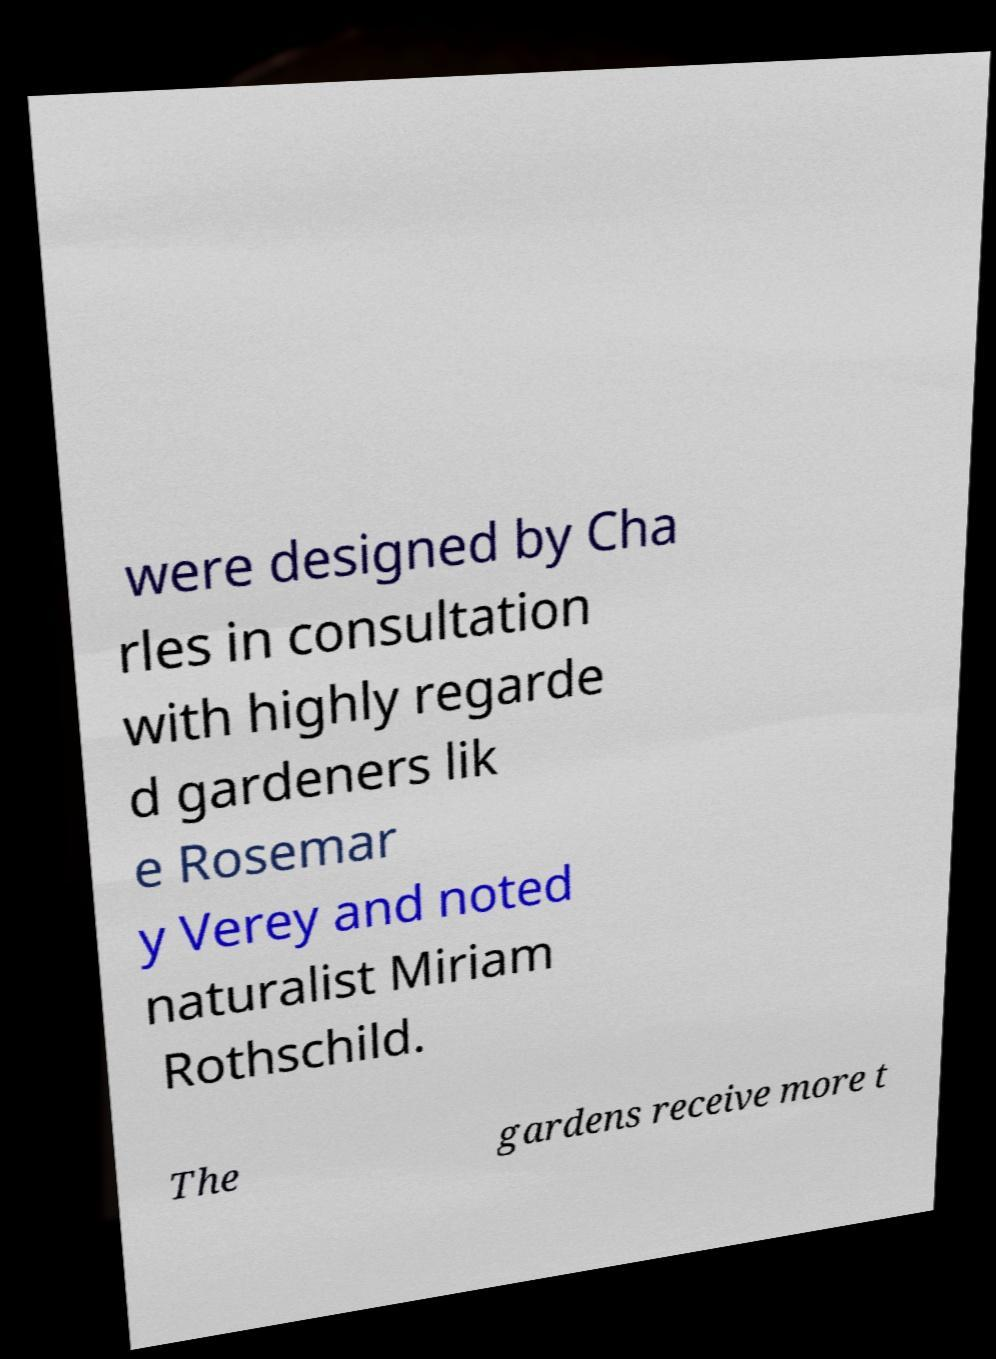Please identify and transcribe the text found in this image. were designed by Cha rles in consultation with highly regarde d gardeners lik e Rosemar y Verey and noted naturalist Miriam Rothschild. The gardens receive more t 